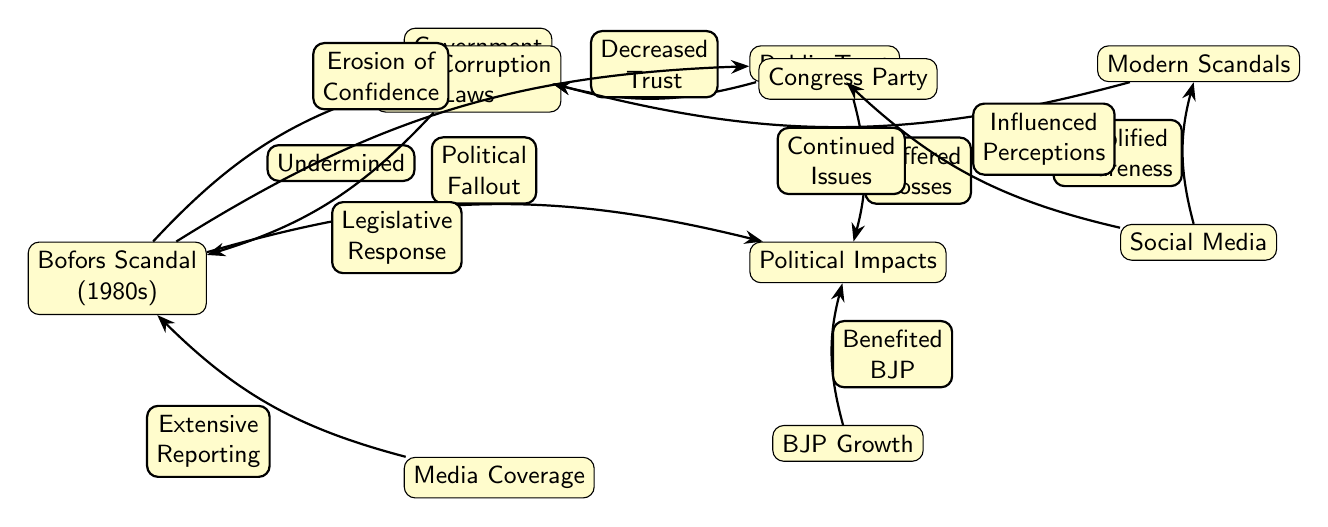What event is the diagram primarily focused on? The diagram highlights the Bofors Scandal, which is indicated in the first node labeled "Bofors Scandal (1980s)."
Answer: Bofors Scandal How does the Bofors Scandal affect government reputation? The diagram shows that the Bofors Scandal "Undermined" the Government Reputation, connecting the Bofors node to the Government Reputation node with this label.
Answer: Undermined What type of media response is indicated in the diagram? The diagram describes the media response as "Extensive Reporting," which originates from the Media Coverage node and points towards the Bofors Scandal node.
Answer: Extensive Reporting What was a political impact of the Bofors scandal on the Congress Party? The diagram indicates that the Congress Party "Suffered Losses" due to the political fallout stemming from the Bofors scandal, as represented in the edge leading from the Congress Party to the Political Impacts node.
Answer: Suffered Losses How did the Bofors scandal influence public trust? The diagram illustrates that the Bofors Scandal led to a "Decreased Trust" in the government, with an edge pointing from the Public Trust node to the Government Reputation node indicating this relationship.
Answer: Decreased Trust What relationship is described between social media and modern scandals? The diagram shows that social media "Amplified Awareness" regarding modern scandals, connecting the Social Media node to the Modern Scandals node with this label.
Answer: Amplified Awareness Which party benefited politically from the fallout of the Bofors scandal? The diagram points out that "Benefited BJP" as one of the political impacts of the Bofors scandal, linking the BJP Growth node to the Political Impacts node to reflect this outcome.
Answer: Benefited BJP What legislative response occurred as a result of the Bofors scandal? The diagram connects the Anti-Corruption Laws node to the Bofors Scandal with the label "Legislative Response," indicating that new laws were introduced as a reaction to the scandal.
Answer: Legislative Response What does modern scandals relate to regarding government reputation? The diagram connects the Modern Scandals node to the Government Reputation with the label "Continued Issues," suggesting an ongoing relationship affecting trust.
Answer: Continued Issues 